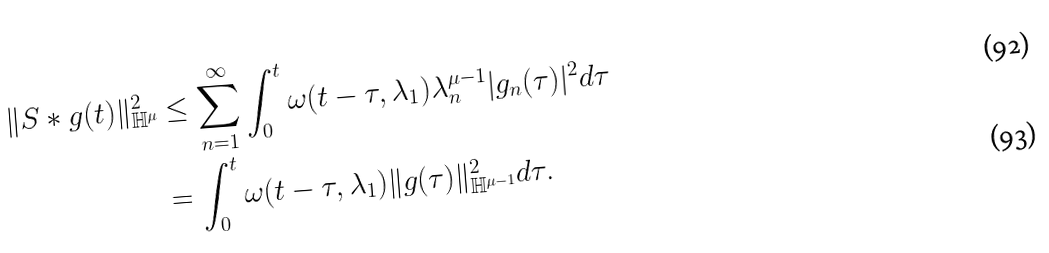<formula> <loc_0><loc_0><loc_500><loc_500>\| S * g ( t ) \| ^ { 2 } _ { \mathbb { H } ^ { \mu } } & \leq \sum _ { n = 1 } ^ { \infty } \int _ { 0 } ^ { t } \omega ( t - \tau , \lambda _ { 1 } ) \lambda _ { n } ^ { \mu - 1 } | g _ { n } ( \tau ) | ^ { 2 } d \tau \\ & = \int _ { 0 } ^ { t } \omega ( t - \tau , \lambda _ { 1 } ) \| g ( \tau ) \| ^ { 2 } _ { \mathbb { H } ^ { \mu - 1 } } d \tau .</formula> 